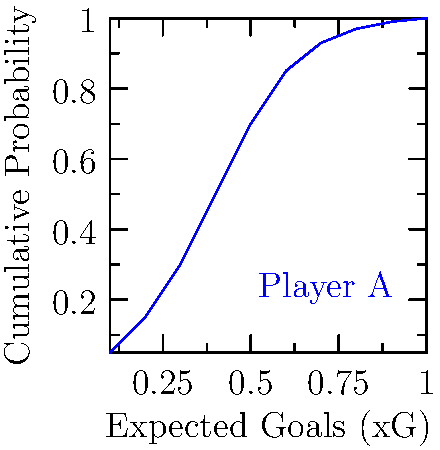Given the cumulative distribution function (CDF) of a player's Expected Goals (xG) performance shown in the graph, what is the probability that the player will have an xG value between 0.3 and 0.7 in their next match? To solve this problem, we need to follow these steps:

1. Understand that the CDF represents the probability of a value being less than or equal to a given point.

2. Find the probability for xG ≤ 0.3:
   From the graph, P(xG ≤ 0.3) ≈ 0.3

3. Find the probability for xG ≤ 0.7:
   From the graph, P(xG ≤ 0.7) ≈ 0.93

4. Calculate the probability of xG being between 0.3 and 0.7:
   P(0.3 < xG ≤ 0.7) = P(xG ≤ 0.7) - P(xG ≤ 0.3)
   
5. Subtract the probabilities:
   P(0.3 < xG ≤ 0.7) ≈ 0.93 - 0.3 = 0.63

Therefore, the probability that the player will have an xG value between 0.3 and 0.7 in their next match is approximately 0.63 or 63%.
Answer: 0.63 (or 63%) 